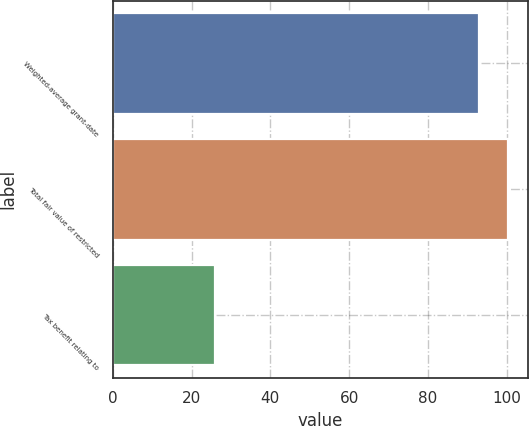<chart> <loc_0><loc_0><loc_500><loc_500><bar_chart><fcel>Weighted-average grant-date<fcel>Total fair value of restricted<fcel>Tax benefit relating to<nl><fcel>93.01<fcel>100.31<fcel>26<nl></chart> 